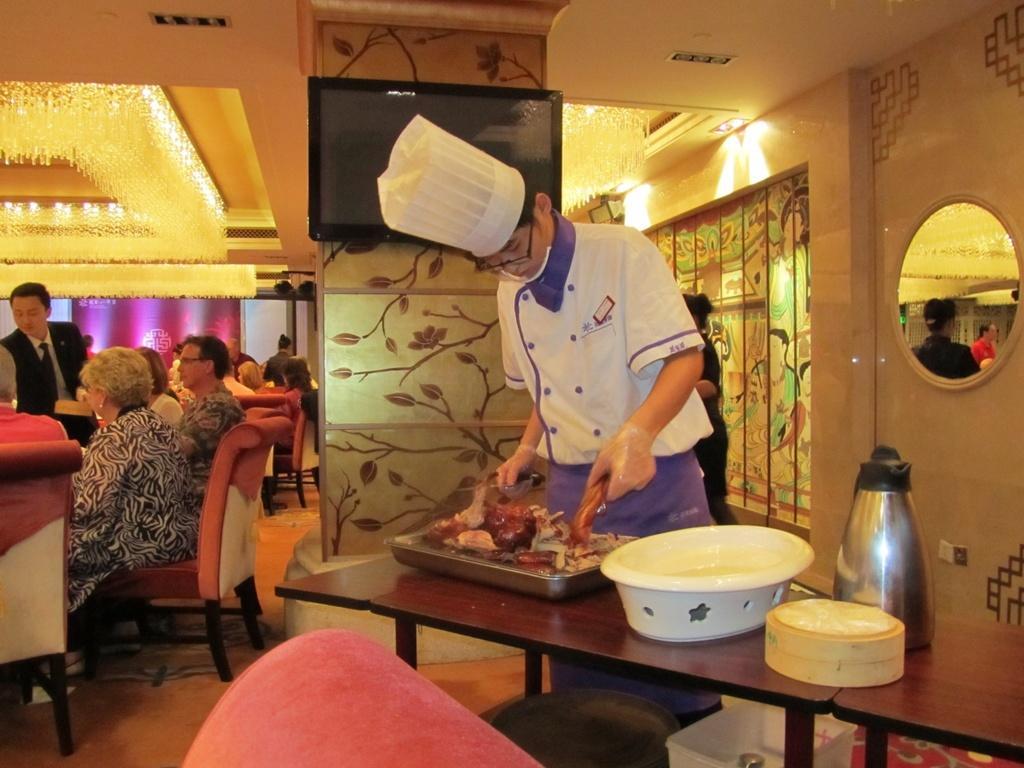In one or two sentences, can you explain what this image depicts? A man is swearing cooking cap, specs and a gloves is holding a food item. In front of him there is a table. On the table there is a flask, bowl and a tray. Behind him there is a wall with a mirror. Also there is a pillar. On the pillar there is a TV. On the left people are sitting on chair. On the ceiling there are lights. 